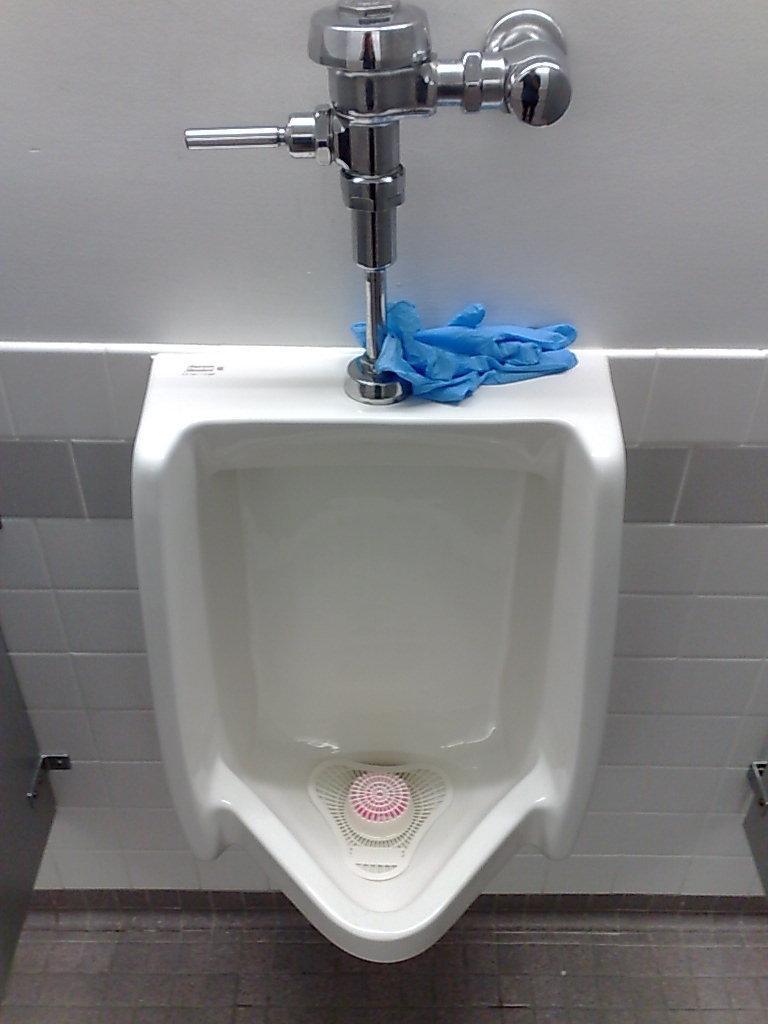Please provide a concise description of this image. In the picture I can see a urinal in the middle of the image and I can see the stainless steel water supply arrangement on the wall. 